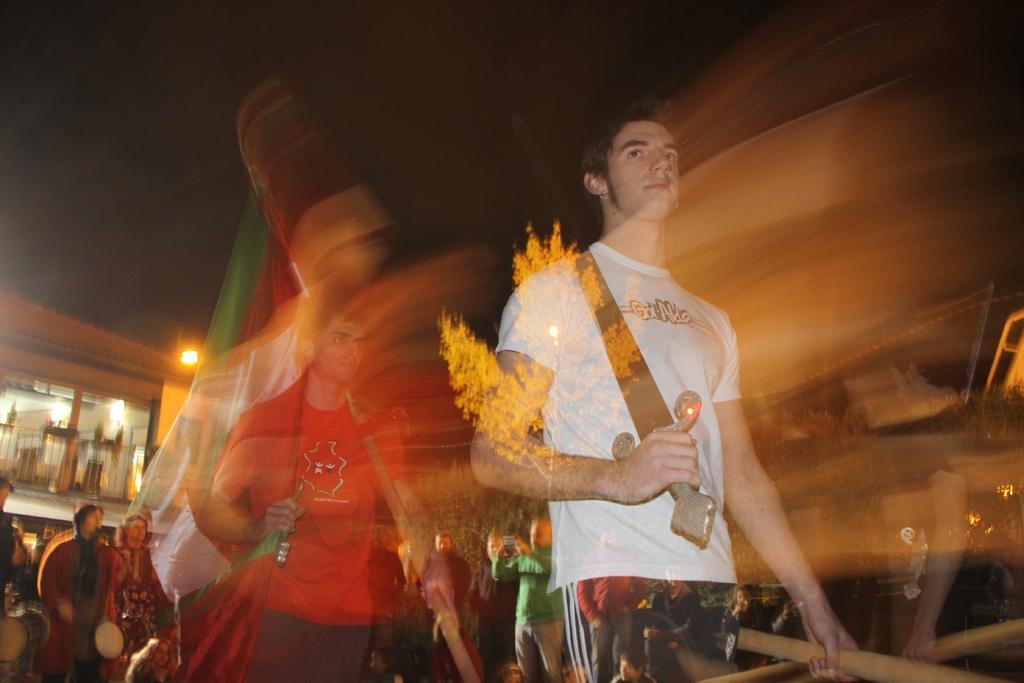Please provide a concise description of this image. In this image there is a person wearing a white T-shirt is holding a sword in his hand. Behind him there is a person holding a flag with one hand and sword with other hand. Left side two persons are standing and holding musical instrument. Few persons are standing. Background there is a building. Top of image there is sky. Right side there are few trees. 